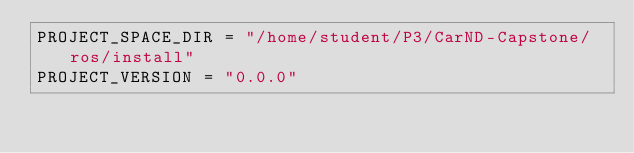<code> <loc_0><loc_0><loc_500><loc_500><_Python_>PROJECT_SPACE_DIR = "/home/student/P3/CarND-Capstone/ros/install"
PROJECT_VERSION = "0.0.0"
</code> 